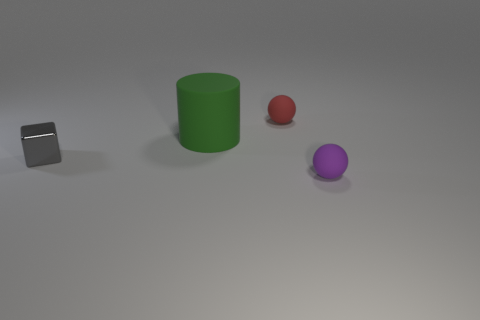Add 3 red matte things. How many objects exist? 7 Subtract 1 cylinders. How many cylinders are left? 0 Subtract all cubes. How many objects are left? 3 Add 3 small purple balls. How many small purple balls are left? 4 Add 3 big purple metal cubes. How many big purple metal cubes exist? 3 Subtract 1 gray blocks. How many objects are left? 3 Subtract all gray spheres. Subtract all brown blocks. How many spheres are left? 2 Subtract all yellow metallic objects. Subtract all large green rubber cylinders. How many objects are left? 3 